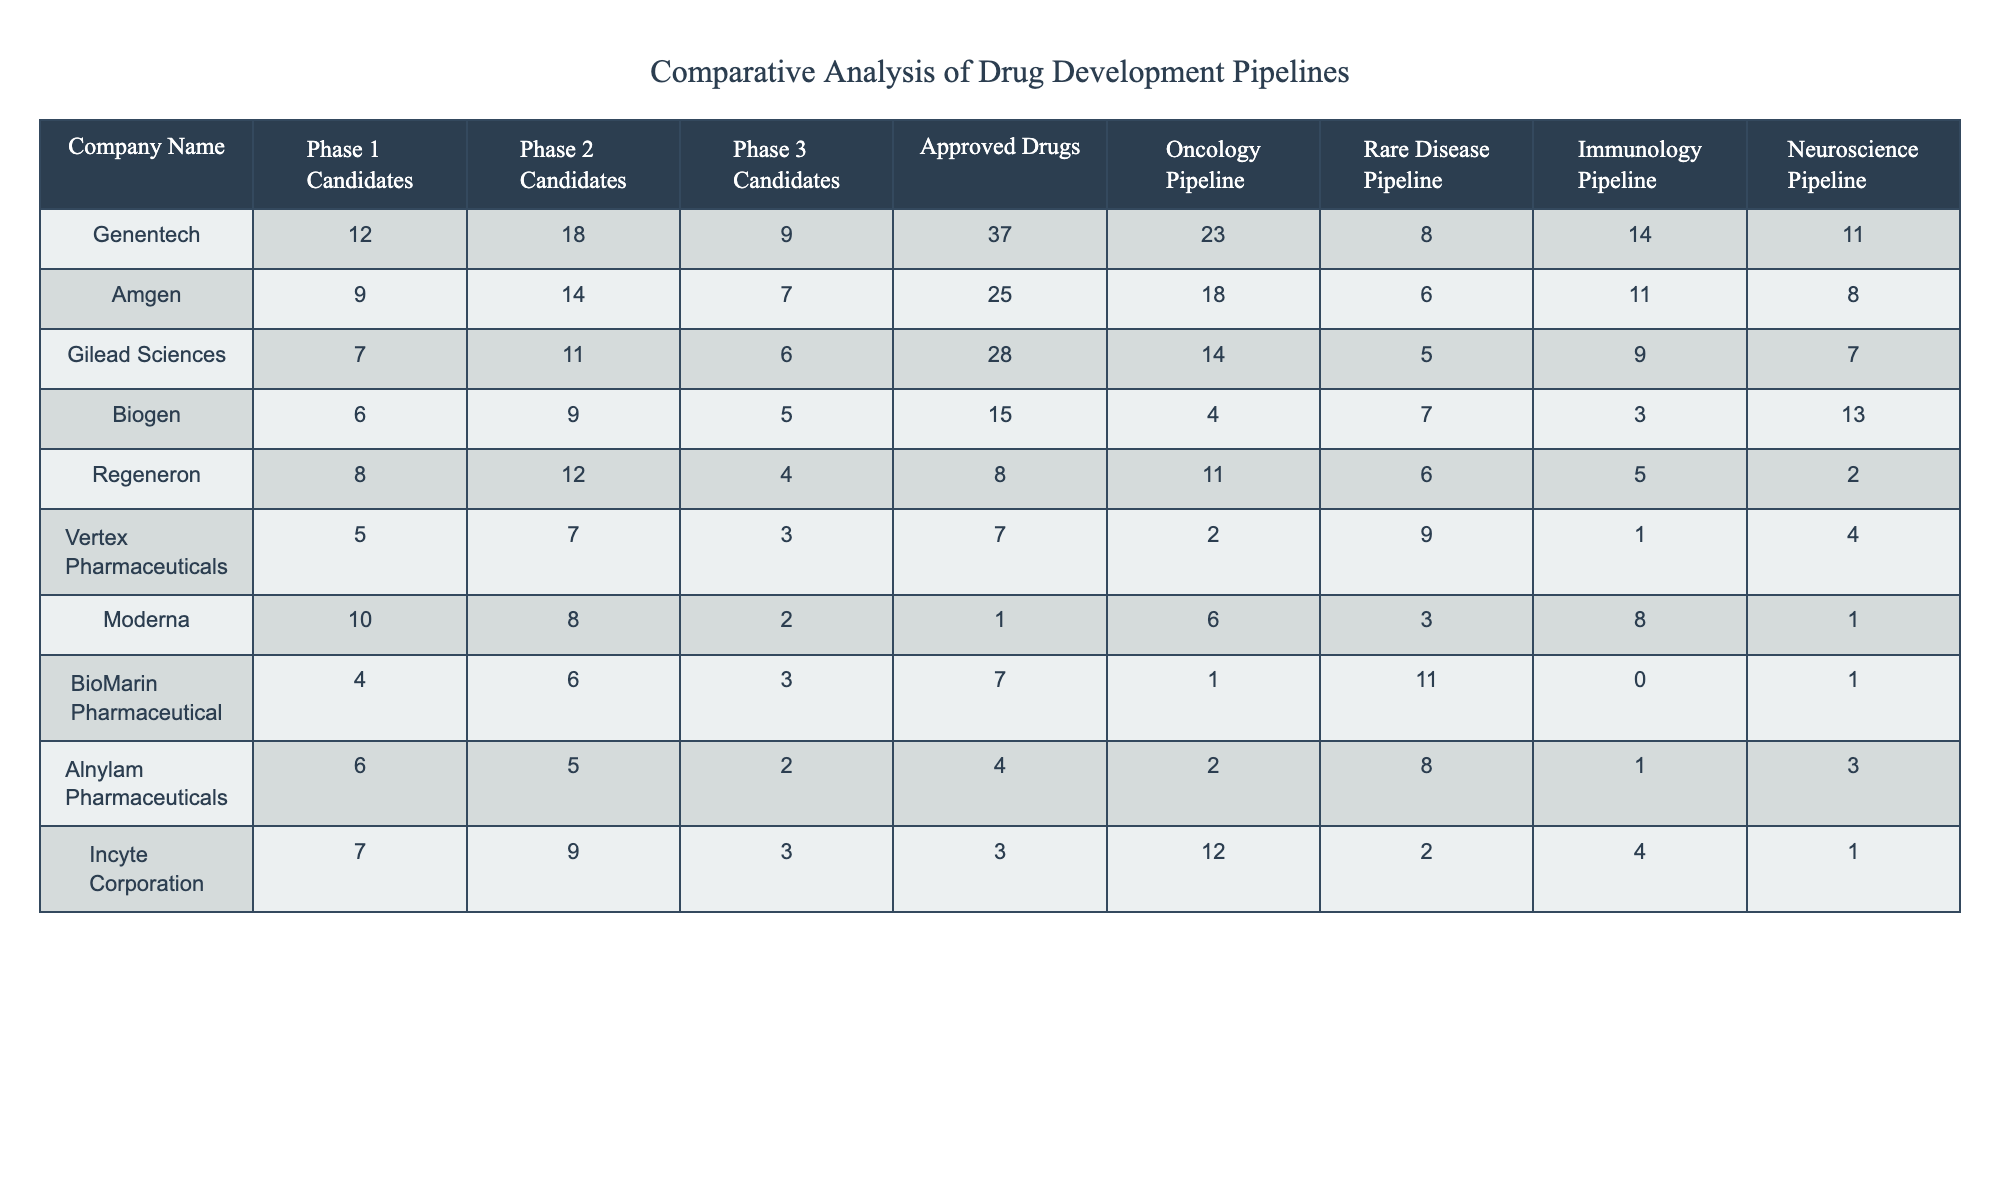What company has the highest number of approved drugs? By checking the "Approved Drugs" column, Genentech has the highest value at 37 approved drugs compared to other companies in the table.
Answer: Genentech How many candidates does Amgen have in Phase 2? The table shows that Amgen has 14 candidates in Phase 2, which is directly stated in the corresponding row.
Answer: 14 Which company has the lowest number of Phase 3 candidates? The lowest value in the "Phase 3 Candidates" column is 2, which belongs to Moderna, as observed in the table.
Answer: Moderna What is the total number of oncology candidates across all companies? Summing the "Oncology Pipeline" values gives: 23 + 18 + 14 + 4 + 11 + 2 + 6 + 1 + 2 + 12 = 92. Therefore, the total number of oncology candidates is 92.
Answer: 92 How does the number of approved drugs for Vertex Pharmaceuticals compare to that of Biogen? Vertex Pharmaceuticals has 7 approved drugs while Biogen has 15, indicating Biogen has more approved drugs by subtracting 7 from 15.
Answer: Biogen has more approved drugs Is the number of Phase 1 candidates for Gilead Sciences greater than the number for Incyte Corporation? Gilead Sciences has 7 Phase 1 candidates, while Incyte Corporation has 7 as well, so they are equal.
Answer: No, they are equal What is the difference in Phase 1 candidates between Regeneron and Amgen? Regeneron has 8 Phase 1 candidates and Amgen has 9. The difference is calculated as 9 - 8 = 1, meaning Amgen has 1 more Phase 1 candidate than Regeneron.
Answer: 1 Which company has the highest count in the Rare Disease Pipeline? In the "Rare Disease Pipeline" column, BioMarin Pharmaceutical has the top count of 11, which is greater than all other companies represented in the table.
Answer: BioMarin Pharmaceutical What is the average number of Phase 3 candidates across all companies? Adding the number of Phase 3 candidates: (9 + 7 + 6 + 5 + 4 + 3 + 2 + 3 + 2 + 4) = 45, and there are 10 companies, so 45/10 = 4.5, making the average number of Phase 3 candidates 4.5.
Answer: 4.5 Does any company have a strong focus on the Neuroscience Pipeline with more than 10 candidates? Looking at the "Neuroscience Pipeline," no company has more than 10 candidates, with Biogen being the highest at 13, but exactly equal does not qualify as a strong focus.
Answer: No, none 